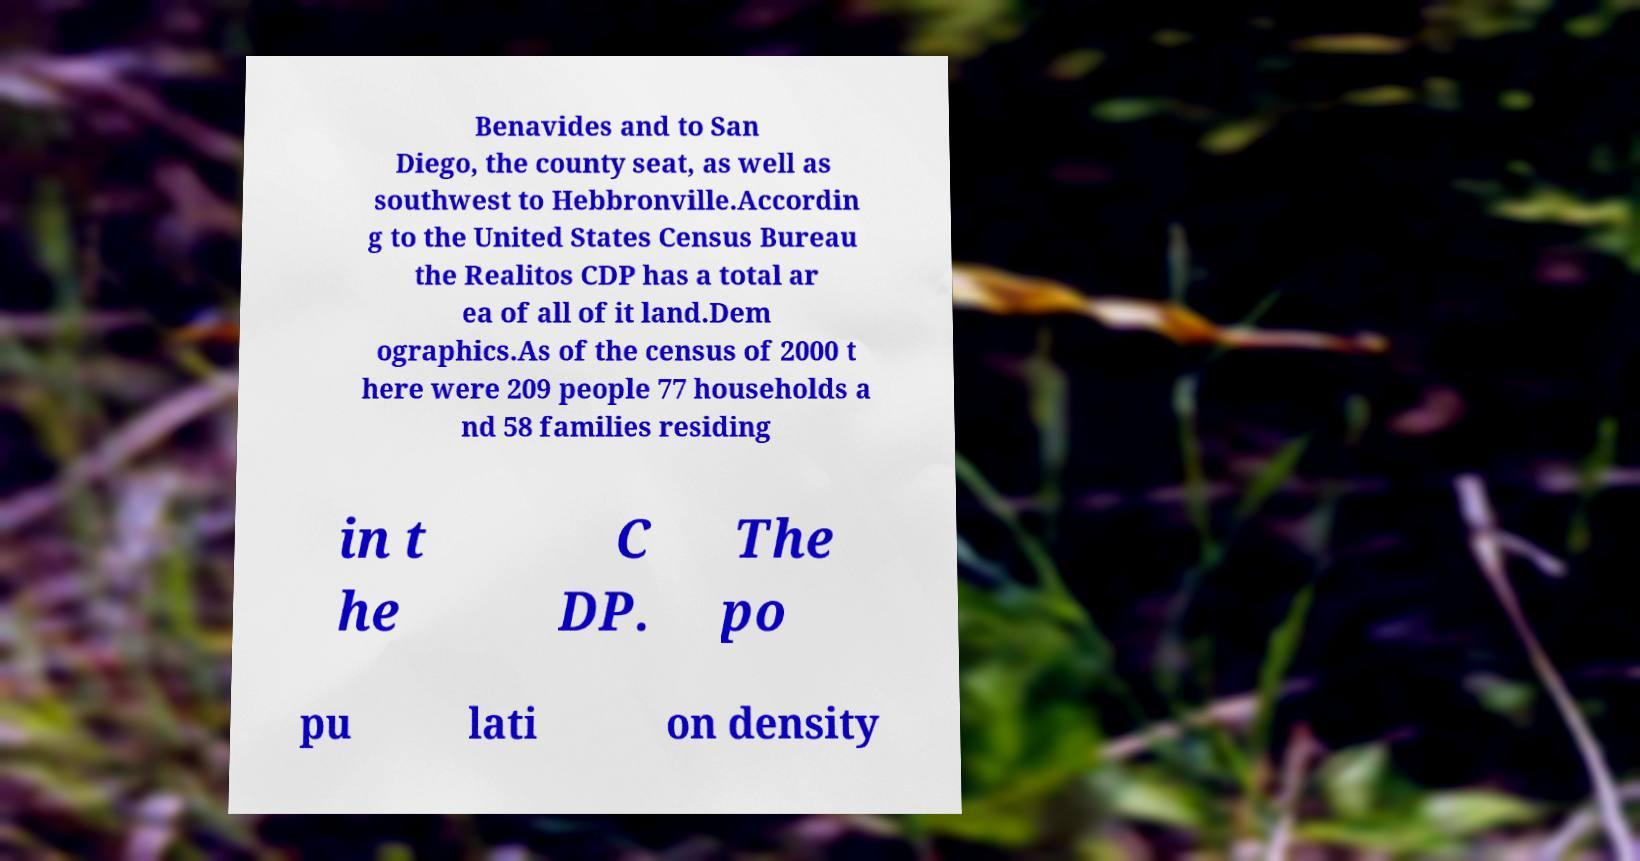Could you extract and type out the text from this image? Benavides and to San Diego, the county seat, as well as southwest to Hebbronville.Accordin g to the United States Census Bureau the Realitos CDP has a total ar ea of all of it land.Dem ographics.As of the census of 2000 t here were 209 people 77 households a nd 58 families residing in t he C DP. The po pu lati on density 